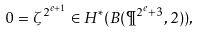Convert formula to latex. <formula><loc_0><loc_0><loc_500><loc_500>0 = \zeta ^ { 2 ^ { e + 1 } } \in H ^ { * } ( B ( \P ^ { 2 ^ { e } + 3 } , 2 ) ) ,</formula> 